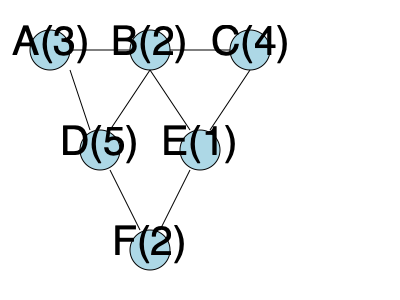Given the directed acyclic graph representing task dependencies and execution times (in parentheses), what is the minimum completion time when scheduling these tasks on two parallel processors using the Critical Path Method (CPM)? Assume zero communication overhead between tasks. To solve this problem using the Critical Path Method (CPM), we need to follow these steps:

1. Identify all paths from start to end:
   Path 1: A → B → E → F (3 + 2 + 1 + 2 = 8)
   Path 2: A → B → C → E → F (3 + 2 + 4 + 1 + 2 = 12)
   Path 3: A → D → F (3 + 5 + 2 = 10)

2. Find the critical path (the longest path):
   The critical path is Path 2 with a length of 12.

3. Schedule tasks on two processors:
   Processor 1: A(0-3), B(3-5), C(5-9), E(9-10), F(10-12)
   Processor 2: D(3-8)

4. Calculate the minimum completion time:
   The minimum completion time is determined by the critical path, which is 12 time units.

This schedule ensures that all dependencies are satisfied and utilizes both processors efficiently. Task D can be executed in parallel with B and C, but it doesn't affect the overall completion time since it's not on the critical path.
Answer: 12 time units 